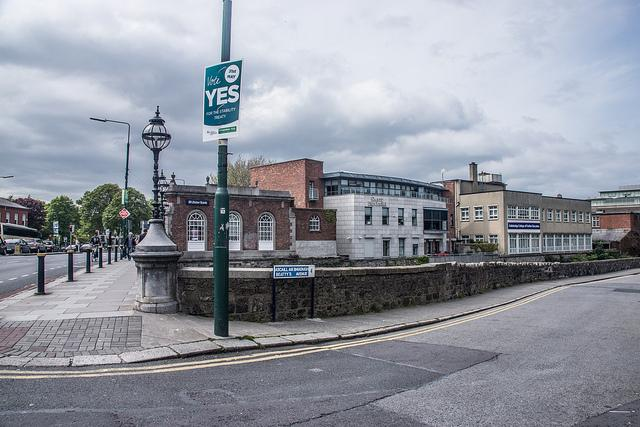What weather might be imminent here? Please explain your reasoning. rain. It is cloudy and the sky is dark. 